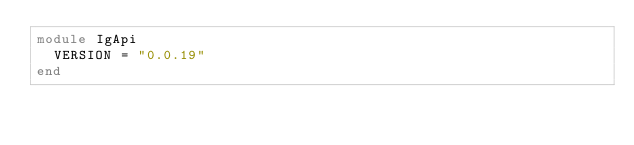Convert code to text. <code><loc_0><loc_0><loc_500><loc_500><_Ruby_>module IgApi
  VERSION = "0.0.19"
end
</code> 